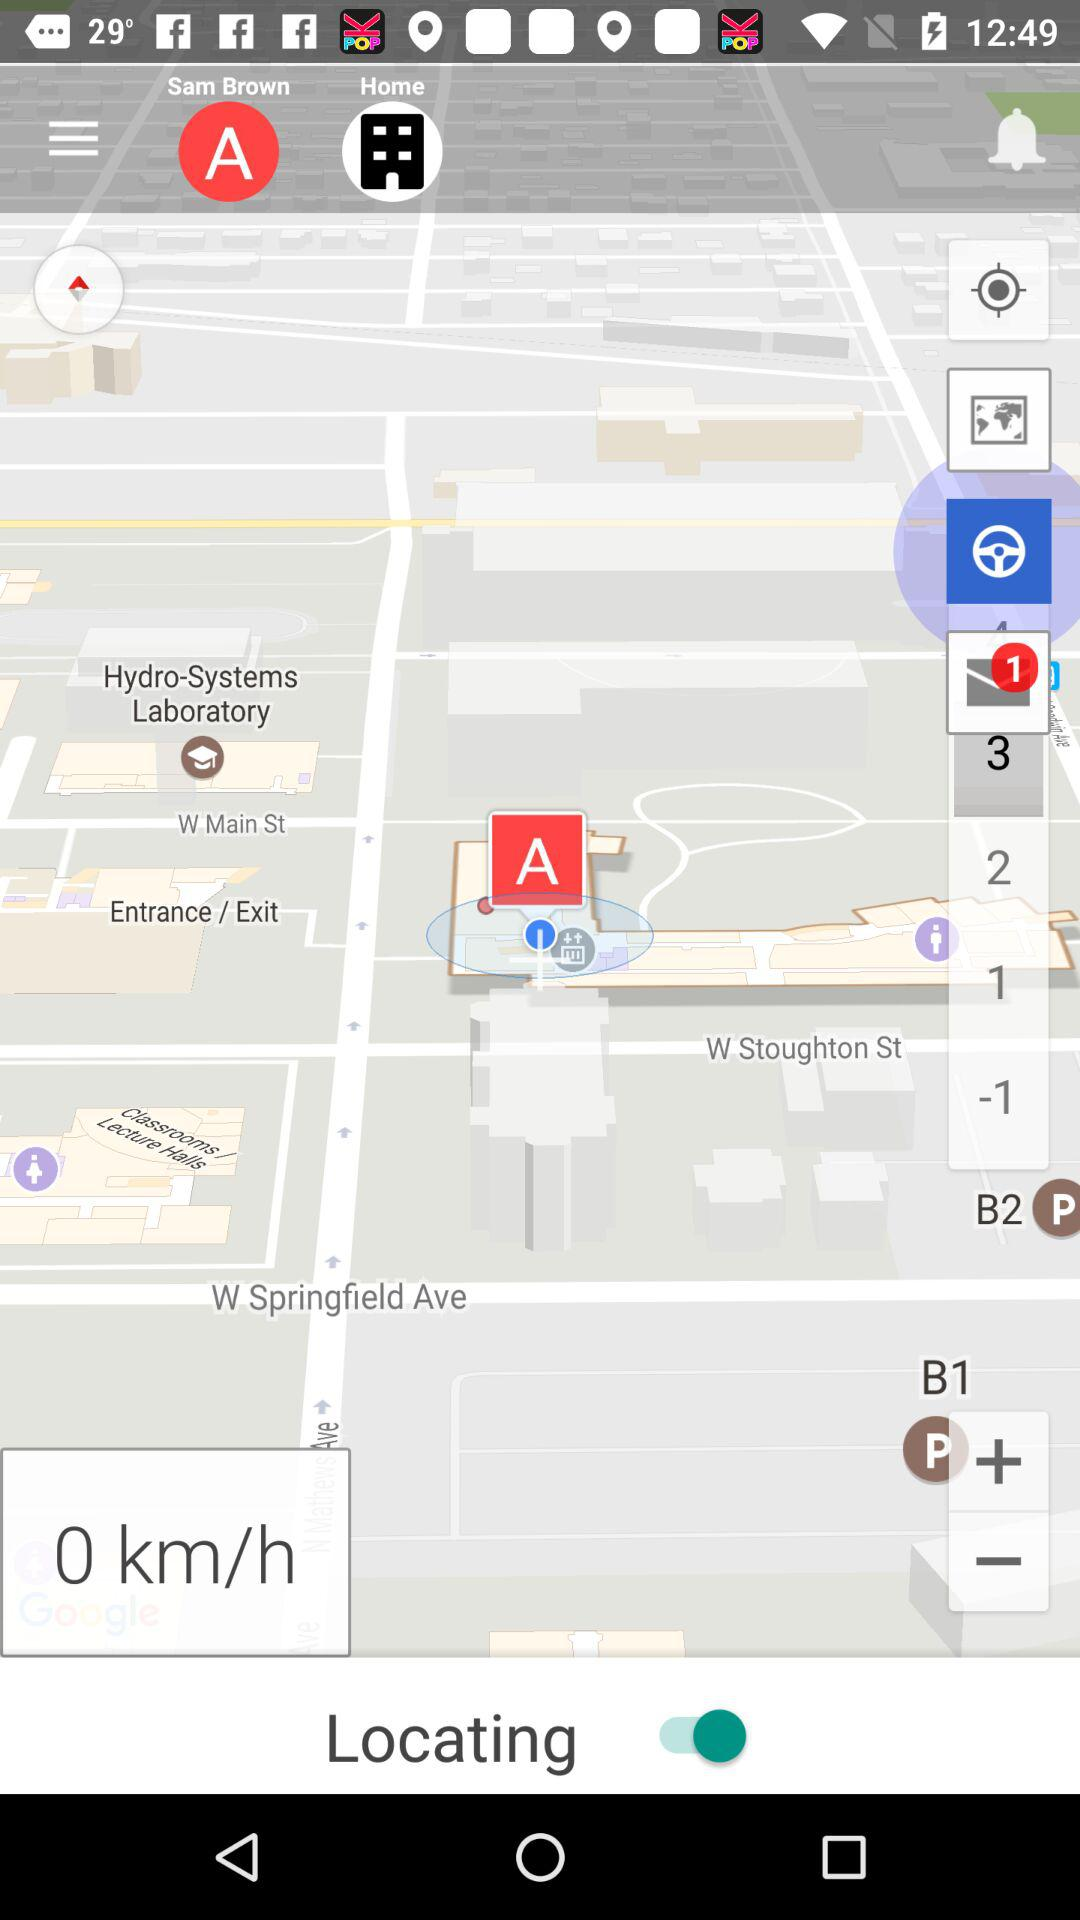What is the user name? The user name is Sam Brown. 